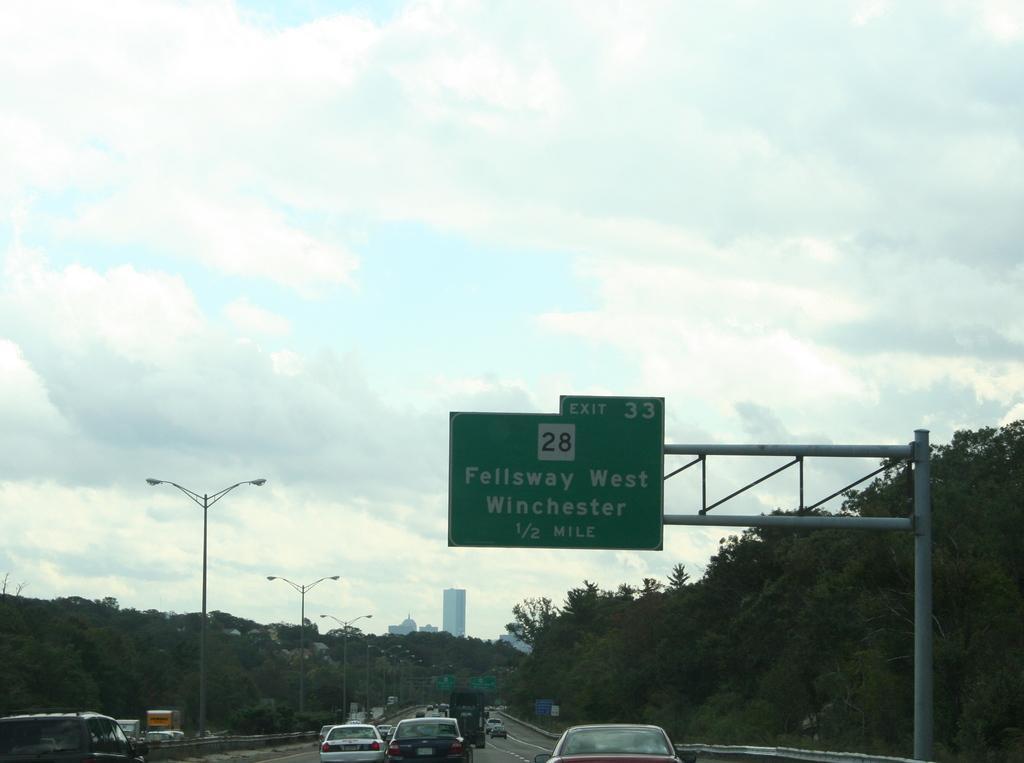Please provide a concise description of this image. This is outside view in this image at the bottom there are some vehicles on a road, and on the right side and left side there are some trees and poles. In the foreground there is one pole and board, on the board there is some text and in the background there are some buildings. At the top of the image the sky. 